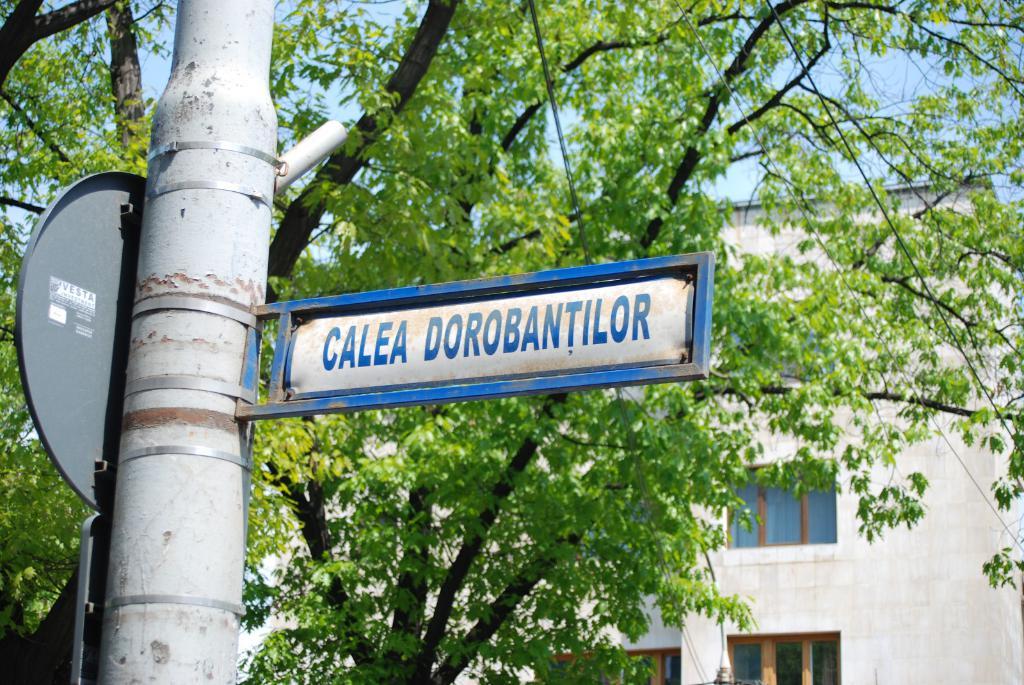What does the sign post say?
Give a very brief answer. Calea dorobantilor. What name is on the back of the round sign?
Keep it short and to the point. Vesta. 